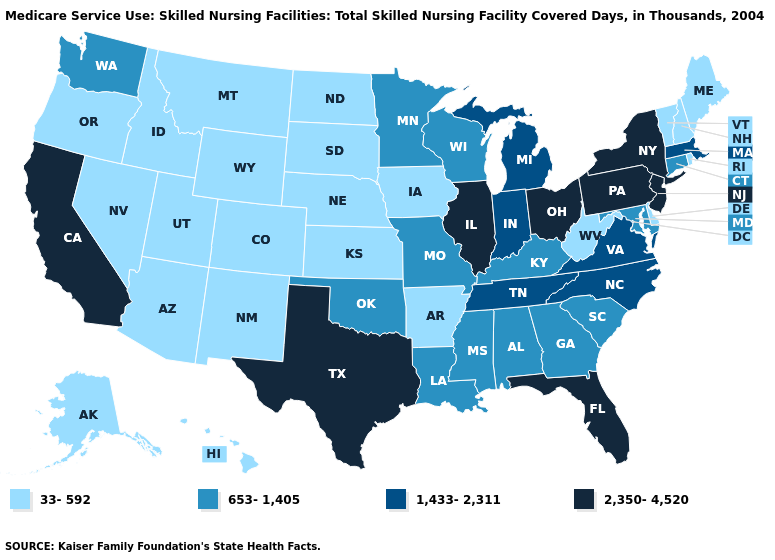Which states have the lowest value in the West?
Be succinct. Alaska, Arizona, Colorado, Hawaii, Idaho, Montana, Nevada, New Mexico, Oregon, Utah, Wyoming. What is the value of Nevada?
Answer briefly. 33-592. What is the value of West Virginia?
Be succinct. 33-592. Name the states that have a value in the range 2,350-4,520?
Answer briefly. California, Florida, Illinois, New Jersey, New York, Ohio, Pennsylvania, Texas. Does the first symbol in the legend represent the smallest category?
Answer briefly. Yes. Does Massachusetts have a higher value than Texas?
Keep it brief. No. Is the legend a continuous bar?
Keep it brief. No. What is the value of Kansas?
Answer briefly. 33-592. Does California have the lowest value in the West?
Quick response, please. No. Which states hav the highest value in the West?
Short answer required. California. Is the legend a continuous bar?
Concise answer only. No. Name the states that have a value in the range 33-592?
Quick response, please. Alaska, Arizona, Arkansas, Colorado, Delaware, Hawaii, Idaho, Iowa, Kansas, Maine, Montana, Nebraska, Nevada, New Hampshire, New Mexico, North Dakota, Oregon, Rhode Island, South Dakota, Utah, Vermont, West Virginia, Wyoming. What is the lowest value in the USA?
Short answer required. 33-592. Name the states that have a value in the range 2,350-4,520?
Keep it brief. California, Florida, Illinois, New Jersey, New York, Ohio, Pennsylvania, Texas. 